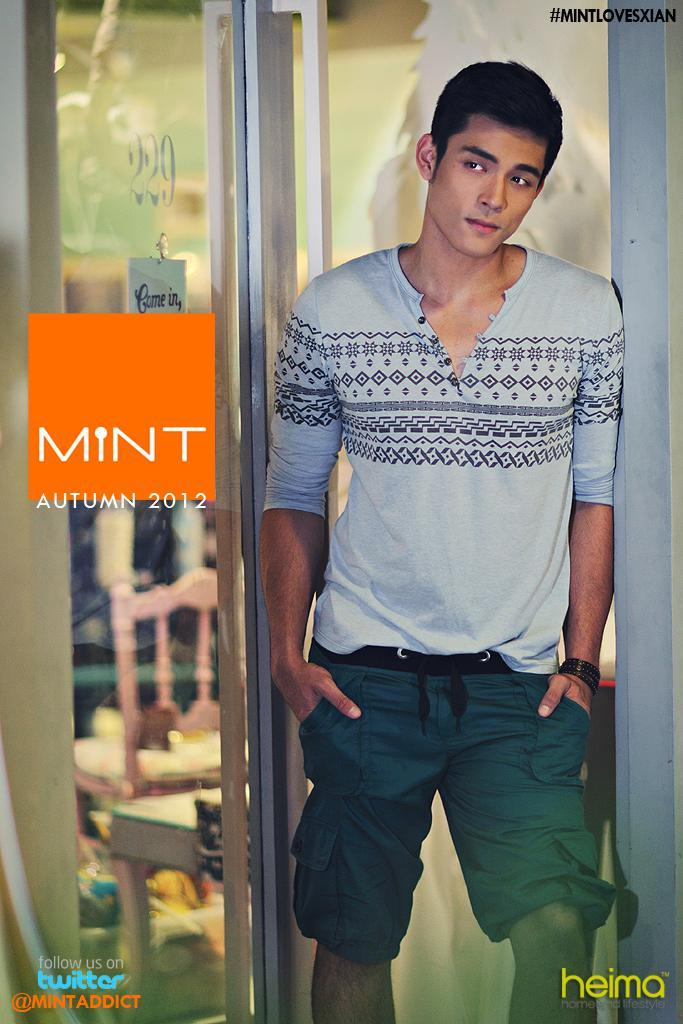What is the main subject of the image? There is a man standing in the image. What can be seen in the background of the image? There is a glass door and boards visible in the background of the image. How many sticks are being used to fold the rule in the image? There are no sticks, folding, or rules present in the image. 